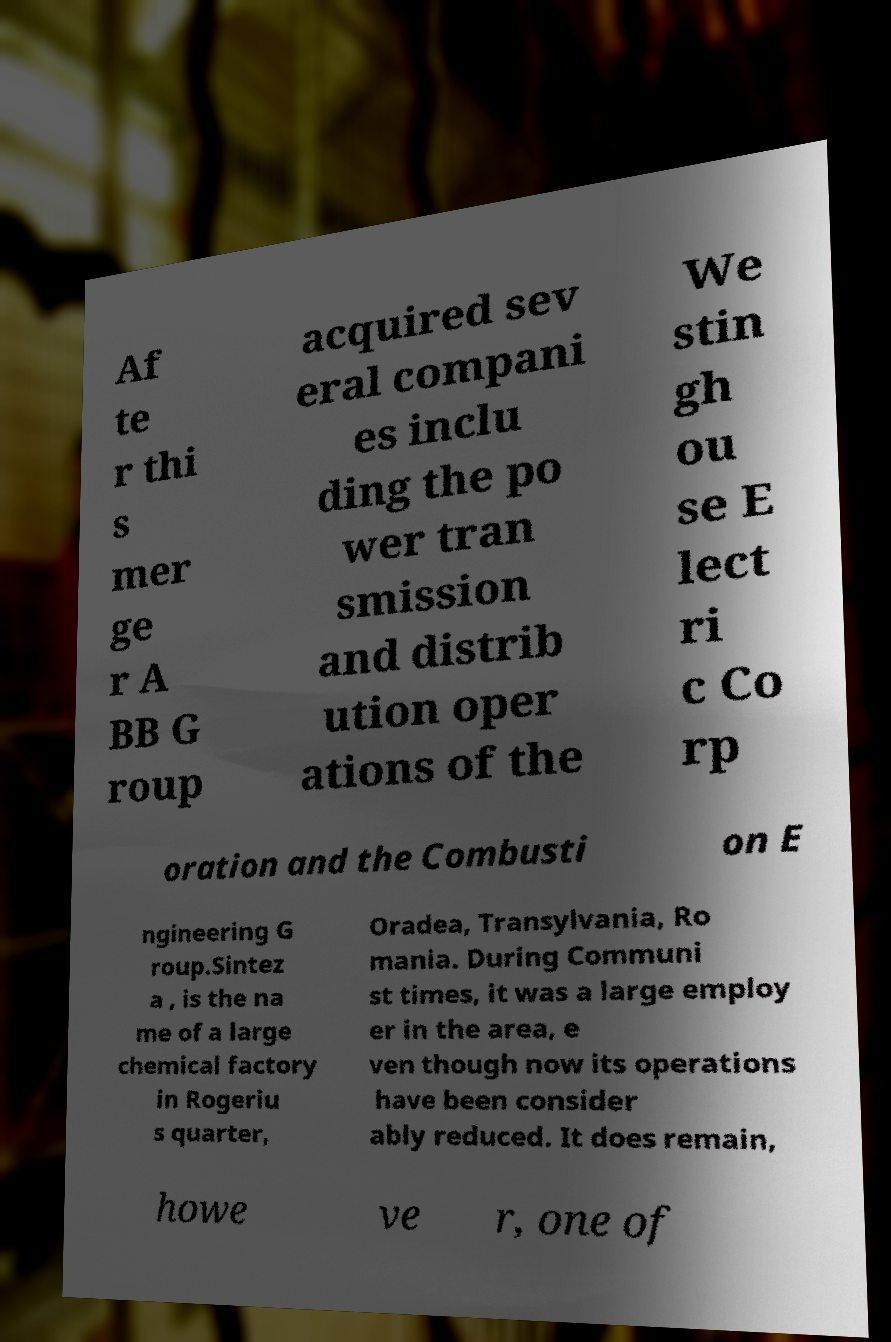Could you assist in decoding the text presented in this image and type it out clearly? Af te r thi s mer ge r A BB G roup acquired sev eral compani es inclu ding the po wer tran smission and distrib ution oper ations of the We stin gh ou se E lect ri c Co rp oration and the Combusti on E ngineering G roup.Sintez a , is the na me of a large chemical factory in Rogeriu s quarter, Oradea, Transylvania, Ro mania. During Communi st times, it was a large employ er in the area, e ven though now its operations have been consider ably reduced. It does remain, howe ve r, one of 